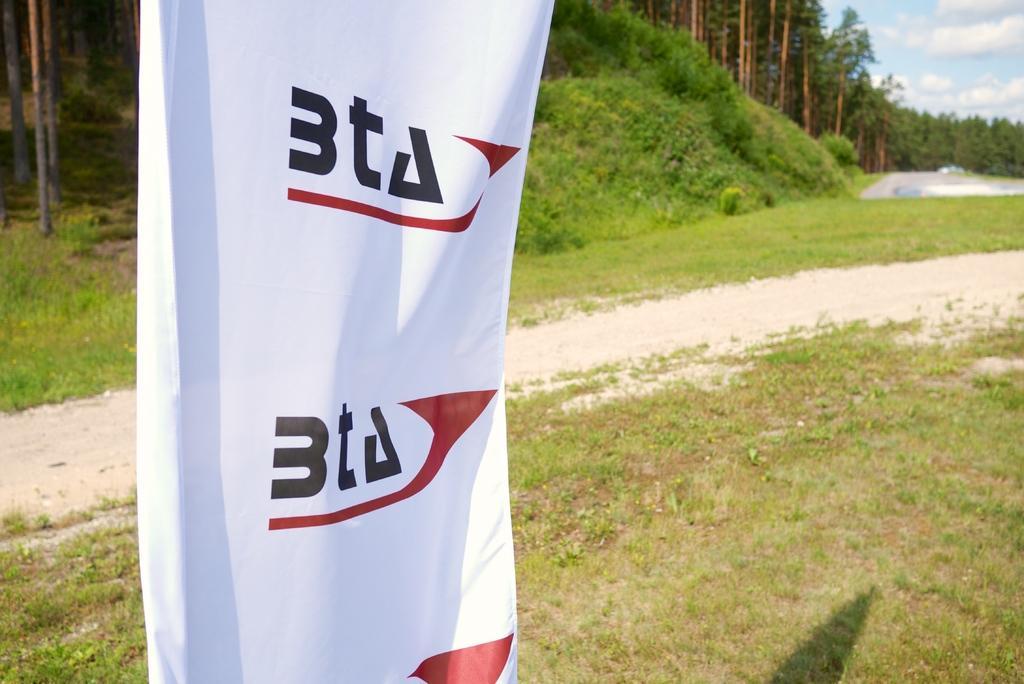How would you summarize this image in a sentence or two? In this image there is a banner with some text. In the background there are trees and a sky. 